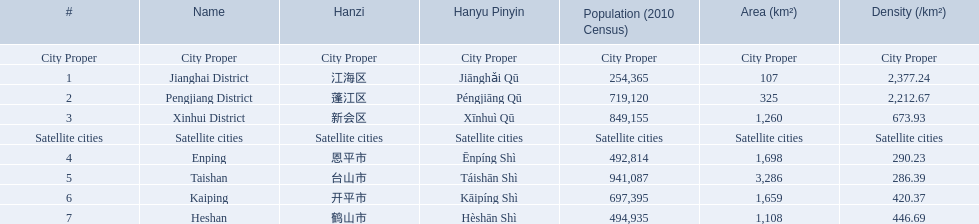What are all the peripheral cities? Enping, Taishan, Kaiping, Heshan. Of these, which has the most inhabitants? Taishan. What municipalities are present in jiangmen? Jianghai District, Pengjiang District, Xinhui District, Enping, Taishan, Kaiping, Heshan. Would you be able to parse every entry in this table? {'header': ['#', 'Name', 'Hanzi', 'Hanyu Pinyin', 'Population (2010 Census)', 'Area (km²)', 'Density (/km²)'], 'rows': [['City Proper', 'City Proper', 'City Proper', 'City Proper', 'City Proper', 'City Proper', 'City Proper'], ['1', 'Jianghai District', '江海区', 'Jiānghǎi Qū', '254,365', '107', '2,377.24'], ['2', 'Pengjiang District', '蓬江区', 'Péngjiāng Qū', '719,120', '325', '2,212.67'], ['3', 'Xinhui District', '新会区', 'Xīnhuì Qū', '849,155', '1,260', '673.93'], ['Satellite cities', 'Satellite cities', 'Satellite cities', 'Satellite cities', 'Satellite cities', 'Satellite cities', 'Satellite cities'], ['4', 'Enping', '恩平市', 'Ēnpíng Shì', '492,814', '1,698', '290.23'], ['5', 'Taishan', '台山市', 'Táishān Shì', '941,087', '3,286', '286.39'], ['6', 'Kaiping', '开平市', 'Kāipíng Shì', '697,395', '1,659', '420.37'], ['7', 'Heshan', '鹤山市', 'Hèshān Shì', '494,935', '1,108', '446.69']]} Among them, which ones are an urban area? Jianghai District, Pengjiang District, Xinhui District. Among them, which one has the least square kilometers in size? Jianghai District. 